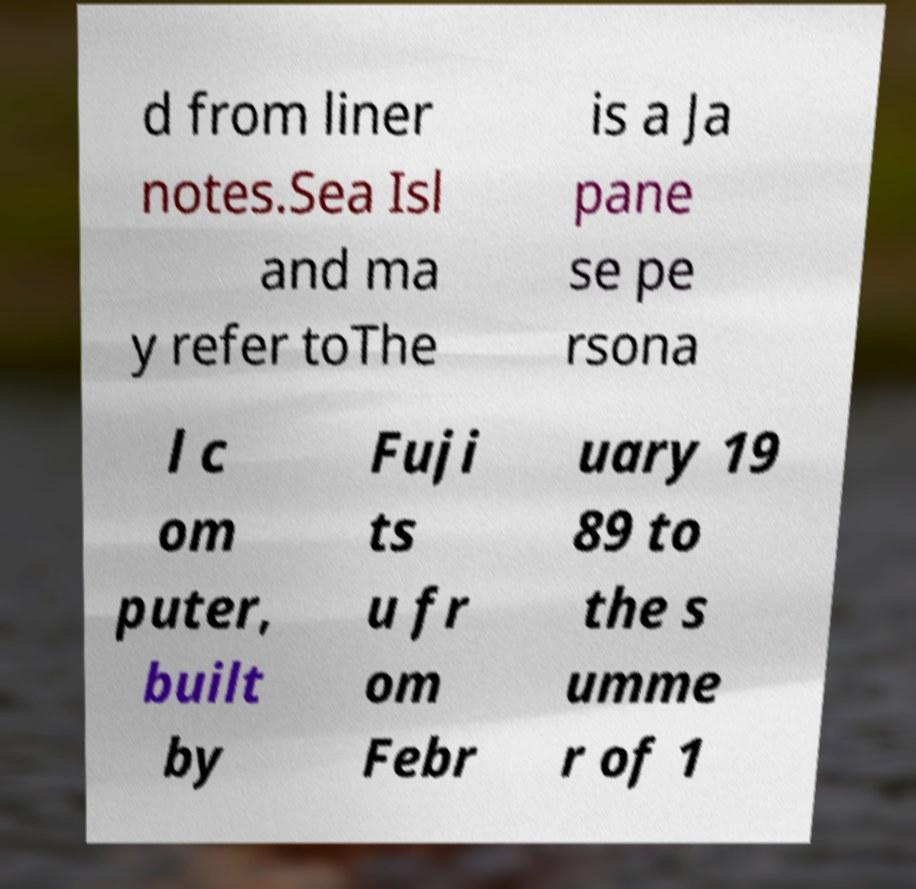Please identify and transcribe the text found in this image. d from liner notes.Sea Isl and ma y refer toThe is a Ja pane se pe rsona l c om puter, built by Fuji ts u fr om Febr uary 19 89 to the s umme r of 1 